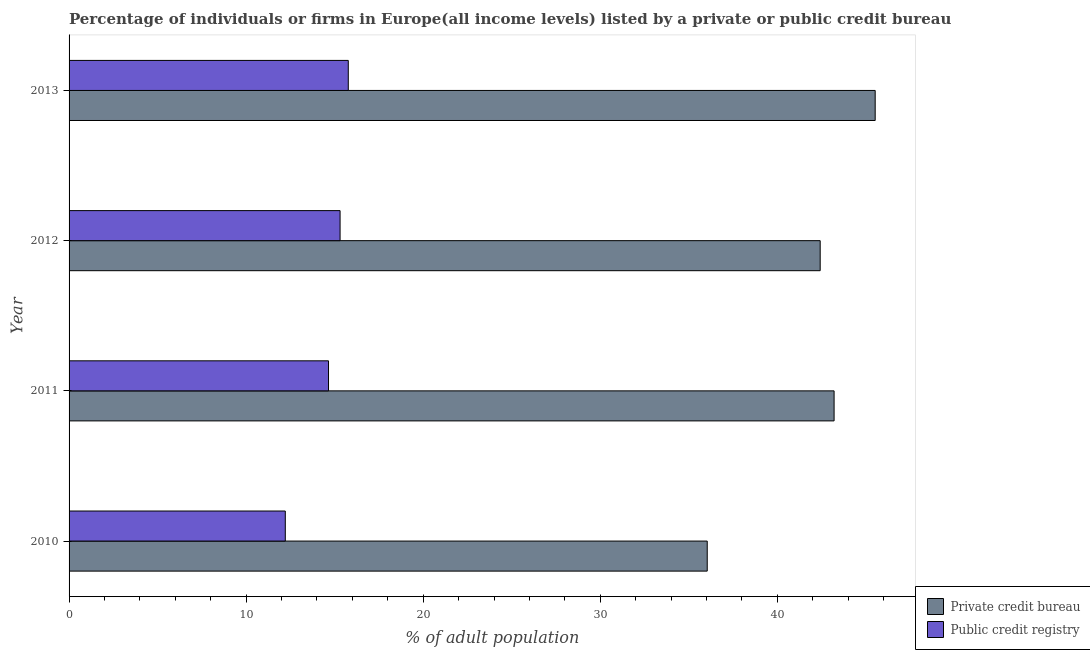How many different coloured bars are there?
Provide a succinct answer. 2. How many groups of bars are there?
Your answer should be very brief. 4. Are the number of bars per tick equal to the number of legend labels?
Offer a very short reply. Yes. Are the number of bars on each tick of the Y-axis equal?
Ensure brevity in your answer.  Yes. What is the percentage of firms listed by private credit bureau in 2011?
Offer a terse response. 43.2. Across all years, what is the maximum percentage of firms listed by public credit bureau?
Provide a short and direct response. 15.77. Across all years, what is the minimum percentage of firms listed by private credit bureau?
Provide a succinct answer. 36.04. In which year was the percentage of firms listed by public credit bureau maximum?
Make the answer very short. 2013. In which year was the percentage of firms listed by public credit bureau minimum?
Keep it short and to the point. 2010. What is the total percentage of firms listed by public credit bureau in the graph?
Your response must be concise. 57.93. What is the difference between the percentage of firms listed by private credit bureau in 2011 and that in 2013?
Your answer should be compact. -2.32. What is the difference between the percentage of firms listed by private credit bureau in 2013 and the percentage of firms listed by public credit bureau in 2010?
Make the answer very short. 33.31. What is the average percentage of firms listed by private credit bureau per year?
Offer a terse response. 41.8. In the year 2013, what is the difference between the percentage of firms listed by private credit bureau and percentage of firms listed by public credit bureau?
Offer a terse response. 29.75. In how many years, is the percentage of firms listed by public credit bureau greater than 18 %?
Make the answer very short. 0. What is the ratio of the percentage of firms listed by public credit bureau in 2012 to that in 2013?
Provide a succinct answer. 0.97. Is the percentage of firms listed by public credit bureau in 2010 less than that in 2013?
Provide a short and direct response. Yes. Is the difference between the percentage of firms listed by public credit bureau in 2010 and 2012 greater than the difference between the percentage of firms listed by private credit bureau in 2010 and 2012?
Provide a succinct answer. Yes. What is the difference between the highest and the second highest percentage of firms listed by private credit bureau?
Your response must be concise. 2.32. What is the difference between the highest and the lowest percentage of firms listed by private credit bureau?
Your answer should be compact. 9.48. Is the sum of the percentage of firms listed by public credit bureau in 2010 and 2011 greater than the maximum percentage of firms listed by private credit bureau across all years?
Offer a very short reply. No. What does the 1st bar from the top in 2011 represents?
Provide a short and direct response. Public credit registry. What does the 2nd bar from the bottom in 2013 represents?
Your response must be concise. Public credit registry. How many bars are there?
Ensure brevity in your answer.  8. Are all the bars in the graph horizontal?
Offer a terse response. Yes. What is the difference between two consecutive major ticks on the X-axis?
Offer a very short reply. 10. Does the graph contain any zero values?
Your answer should be very brief. No. What is the title of the graph?
Your answer should be very brief. Percentage of individuals or firms in Europe(all income levels) listed by a private or public credit bureau. Does "Formally registered" appear as one of the legend labels in the graph?
Ensure brevity in your answer.  No. What is the label or title of the X-axis?
Your answer should be compact. % of adult population. What is the % of adult population of Private credit bureau in 2010?
Provide a short and direct response. 36.04. What is the % of adult population in Public credit registry in 2010?
Make the answer very short. 12.21. What is the % of adult population of Private credit bureau in 2011?
Your answer should be compact. 43.2. What is the % of adult population of Public credit registry in 2011?
Provide a succinct answer. 14.65. What is the % of adult population of Private credit bureau in 2012?
Give a very brief answer. 42.42. What is the % of adult population of Public credit registry in 2012?
Ensure brevity in your answer.  15.3. What is the % of adult population of Private credit bureau in 2013?
Keep it short and to the point. 45.52. What is the % of adult population in Public credit registry in 2013?
Offer a very short reply. 15.77. Across all years, what is the maximum % of adult population in Private credit bureau?
Ensure brevity in your answer.  45.52. Across all years, what is the maximum % of adult population in Public credit registry?
Offer a terse response. 15.77. Across all years, what is the minimum % of adult population in Private credit bureau?
Your answer should be compact. 36.04. Across all years, what is the minimum % of adult population of Public credit registry?
Keep it short and to the point. 12.21. What is the total % of adult population in Private credit bureau in the graph?
Offer a terse response. 167.18. What is the total % of adult population in Public credit registry in the graph?
Provide a short and direct response. 57.93. What is the difference between the % of adult population of Private credit bureau in 2010 and that in 2011?
Offer a terse response. -7.16. What is the difference between the % of adult population in Public credit registry in 2010 and that in 2011?
Your answer should be very brief. -2.44. What is the difference between the % of adult population in Private credit bureau in 2010 and that in 2012?
Offer a terse response. -6.38. What is the difference between the % of adult population of Public credit registry in 2010 and that in 2012?
Give a very brief answer. -3.09. What is the difference between the % of adult population of Private credit bureau in 2010 and that in 2013?
Give a very brief answer. -9.48. What is the difference between the % of adult population of Public credit registry in 2010 and that in 2013?
Offer a very short reply. -3.56. What is the difference between the % of adult population of Private credit bureau in 2011 and that in 2012?
Give a very brief answer. 0.79. What is the difference between the % of adult population in Public credit registry in 2011 and that in 2012?
Provide a short and direct response. -0.65. What is the difference between the % of adult population in Private credit bureau in 2011 and that in 2013?
Provide a succinct answer. -2.32. What is the difference between the % of adult population of Public credit registry in 2011 and that in 2013?
Ensure brevity in your answer.  -1.12. What is the difference between the % of adult population of Private credit bureau in 2012 and that in 2013?
Ensure brevity in your answer.  -3.11. What is the difference between the % of adult population in Public credit registry in 2012 and that in 2013?
Your answer should be very brief. -0.46. What is the difference between the % of adult population of Private credit bureau in 2010 and the % of adult population of Public credit registry in 2011?
Provide a succinct answer. 21.39. What is the difference between the % of adult population of Private credit bureau in 2010 and the % of adult population of Public credit registry in 2012?
Ensure brevity in your answer.  20.73. What is the difference between the % of adult population in Private credit bureau in 2010 and the % of adult population in Public credit registry in 2013?
Make the answer very short. 20.27. What is the difference between the % of adult population of Private credit bureau in 2011 and the % of adult population of Public credit registry in 2012?
Provide a short and direct response. 27.9. What is the difference between the % of adult population of Private credit bureau in 2011 and the % of adult population of Public credit registry in 2013?
Provide a short and direct response. 27.43. What is the difference between the % of adult population in Private credit bureau in 2012 and the % of adult population in Public credit registry in 2013?
Your answer should be compact. 26.65. What is the average % of adult population in Private credit bureau per year?
Provide a short and direct response. 41.79. What is the average % of adult population in Public credit registry per year?
Provide a succinct answer. 14.48. In the year 2010, what is the difference between the % of adult population of Private credit bureau and % of adult population of Public credit registry?
Provide a short and direct response. 23.83. In the year 2011, what is the difference between the % of adult population in Private credit bureau and % of adult population in Public credit registry?
Offer a terse response. 28.55. In the year 2012, what is the difference between the % of adult population of Private credit bureau and % of adult population of Public credit registry?
Ensure brevity in your answer.  27.11. In the year 2013, what is the difference between the % of adult population of Private credit bureau and % of adult population of Public credit registry?
Offer a terse response. 29.76. What is the ratio of the % of adult population in Private credit bureau in 2010 to that in 2011?
Keep it short and to the point. 0.83. What is the ratio of the % of adult population in Public credit registry in 2010 to that in 2011?
Provide a succinct answer. 0.83. What is the ratio of the % of adult population of Private credit bureau in 2010 to that in 2012?
Offer a very short reply. 0.85. What is the ratio of the % of adult population of Public credit registry in 2010 to that in 2012?
Ensure brevity in your answer.  0.8. What is the ratio of the % of adult population of Private credit bureau in 2010 to that in 2013?
Offer a very short reply. 0.79. What is the ratio of the % of adult population in Public credit registry in 2010 to that in 2013?
Give a very brief answer. 0.77. What is the ratio of the % of adult population of Private credit bureau in 2011 to that in 2012?
Ensure brevity in your answer.  1.02. What is the ratio of the % of adult population of Public credit registry in 2011 to that in 2012?
Your response must be concise. 0.96. What is the ratio of the % of adult population of Private credit bureau in 2011 to that in 2013?
Keep it short and to the point. 0.95. What is the ratio of the % of adult population of Public credit registry in 2011 to that in 2013?
Give a very brief answer. 0.93. What is the ratio of the % of adult population in Private credit bureau in 2012 to that in 2013?
Provide a succinct answer. 0.93. What is the ratio of the % of adult population in Public credit registry in 2012 to that in 2013?
Give a very brief answer. 0.97. What is the difference between the highest and the second highest % of adult population in Private credit bureau?
Provide a succinct answer. 2.32. What is the difference between the highest and the second highest % of adult population in Public credit registry?
Offer a very short reply. 0.46. What is the difference between the highest and the lowest % of adult population of Private credit bureau?
Give a very brief answer. 9.48. What is the difference between the highest and the lowest % of adult population of Public credit registry?
Your response must be concise. 3.56. 